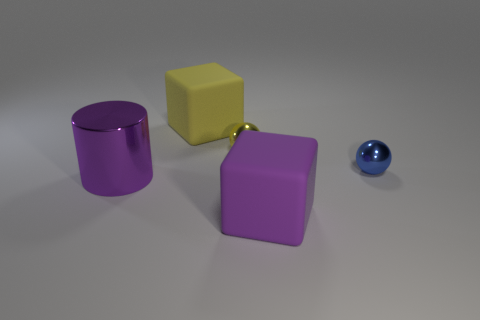Subtract all cylinders. How many objects are left? 4 Subtract all blue cylinders. How many yellow blocks are left? 1 Subtract all blue things. Subtract all yellow matte blocks. How many objects are left? 3 Add 3 purple rubber blocks. How many purple rubber blocks are left? 4 Add 4 large brown things. How many large brown things exist? 4 Add 3 large yellow cylinders. How many objects exist? 8 Subtract 1 yellow cubes. How many objects are left? 4 Subtract 1 spheres. How many spheres are left? 1 Subtract all purple spheres. Subtract all cyan cylinders. How many spheres are left? 2 